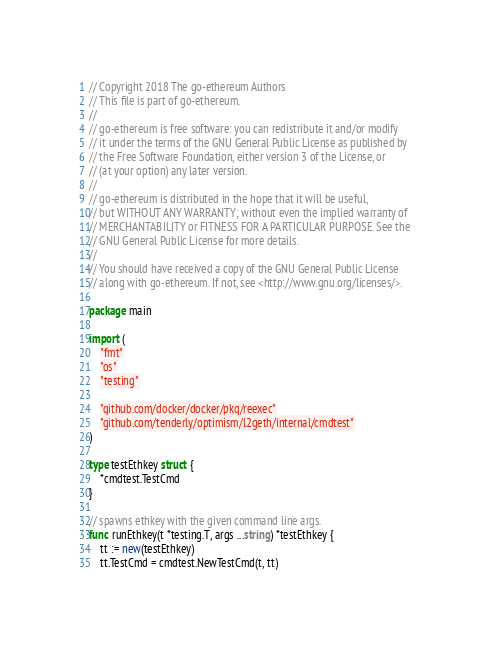<code> <loc_0><loc_0><loc_500><loc_500><_Go_>// Copyright 2018 The go-ethereum Authors
// This file is part of go-ethereum.
//
// go-ethereum is free software: you can redistribute it and/or modify
// it under the terms of the GNU General Public License as published by
// the Free Software Foundation, either version 3 of the License, or
// (at your option) any later version.
//
// go-ethereum is distributed in the hope that it will be useful,
// but WITHOUT ANY WARRANTY; without even the implied warranty of
// MERCHANTABILITY or FITNESS FOR A PARTICULAR PURPOSE. See the
// GNU General Public License for more details.
//
// You should have received a copy of the GNU General Public License
// along with go-ethereum. If not, see <http://www.gnu.org/licenses/>.

package main

import (
	"fmt"
	"os"
	"testing"

	"github.com/docker/docker/pkg/reexec"
	"github.com/tenderly/optimism/l2geth/internal/cmdtest"
)

type testEthkey struct {
	*cmdtest.TestCmd
}

// spawns ethkey with the given command line args.
func runEthkey(t *testing.T, args ...string) *testEthkey {
	tt := new(testEthkey)
	tt.TestCmd = cmdtest.NewTestCmd(t, tt)</code> 